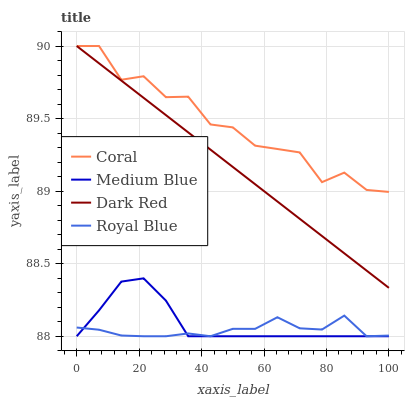Does Medium Blue have the minimum area under the curve?
Answer yes or no. No. Does Medium Blue have the maximum area under the curve?
Answer yes or no. No. Is Medium Blue the smoothest?
Answer yes or no. No. Is Medium Blue the roughest?
Answer yes or no. No. Does Coral have the lowest value?
Answer yes or no. No. Does Medium Blue have the highest value?
Answer yes or no. No. Is Royal Blue less than Coral?
Answer yes or no. Yes. Is Coral greater than Medium Blue?
Answer yes or no. Yes. Does Royal Blue intersect Coral?
Answer yes or no. No. 